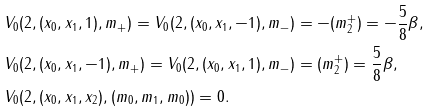<formula> <loc_0><loc_0><loc_500><loc_500>& V _ { 0 } ( 2 , ( x _ { 0 } , x _ { 1 } , 1 ) , m _ { + } ) = V _ { 0 } ( 2 , ( x _ { 0 } , x _ { 1 } , - 1 ) , m _ { - } ) = - ( m _ { 2 } ^ { + } ) = - \frac { 5 } { 8 } \beta , \\ & V _ { 0 } ( 2 , ( x _ { 0 } , x _ { 1 } , - 1 ) , m _ { + } ) = V _ { 0 } ( 2 , ( x _ { 0 } , x _ { 1 } , 1 ) , m _ { - } ) = ( m _ { 2 } ^ { + } ) = \frac { 5 } { 8 } \beta , \\ & V _ { 0 } ( 2 , ( x _ { 0 } , x _ { 1 } , x _ { 2 } ) , ( m _ { 0 } , m _ { 1 } , m _ { 0 } ) ) = 0 .</formula> 